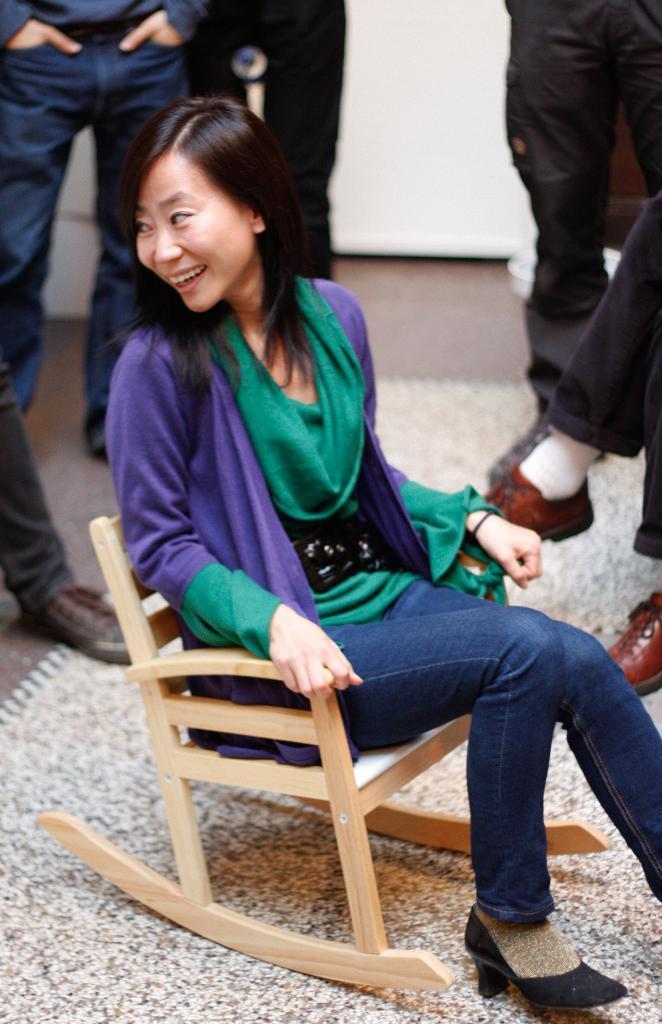Can you describe this image briefly? In this Image I see a woman who is smiling and sitting on a chair. In the background I see few people who are standing. 